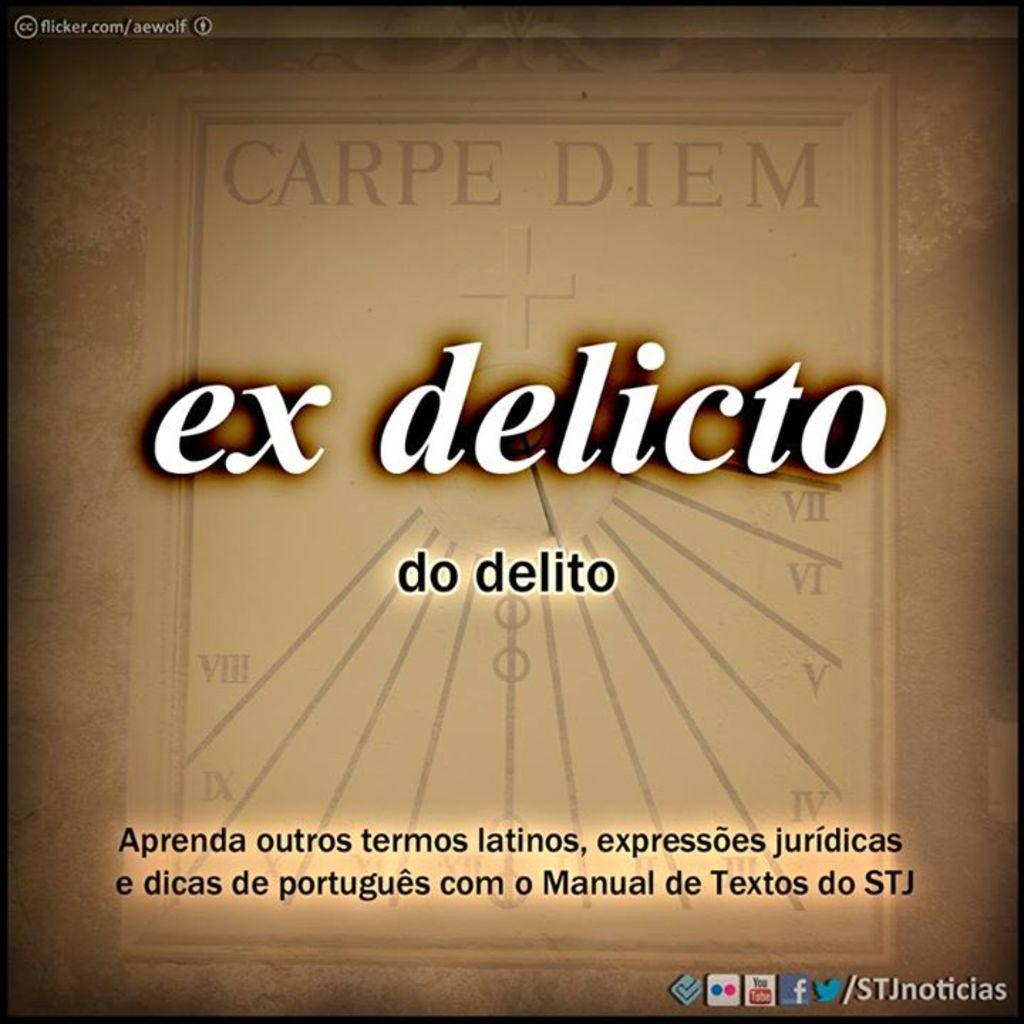<image>
Create a compact narrative representing the image presented. A brown image has the term "carpe diem" at the top. 